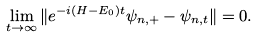Convert formula to latex. <formula><loc_0><loc_0><loc_500><loc_500>\lim _ { t \to \infty } \| e ^ { - i ( H - E _ { 0 } ) t } \psi _ { n , + } - \psi _ { n , t } \| = 0 .</formula> 